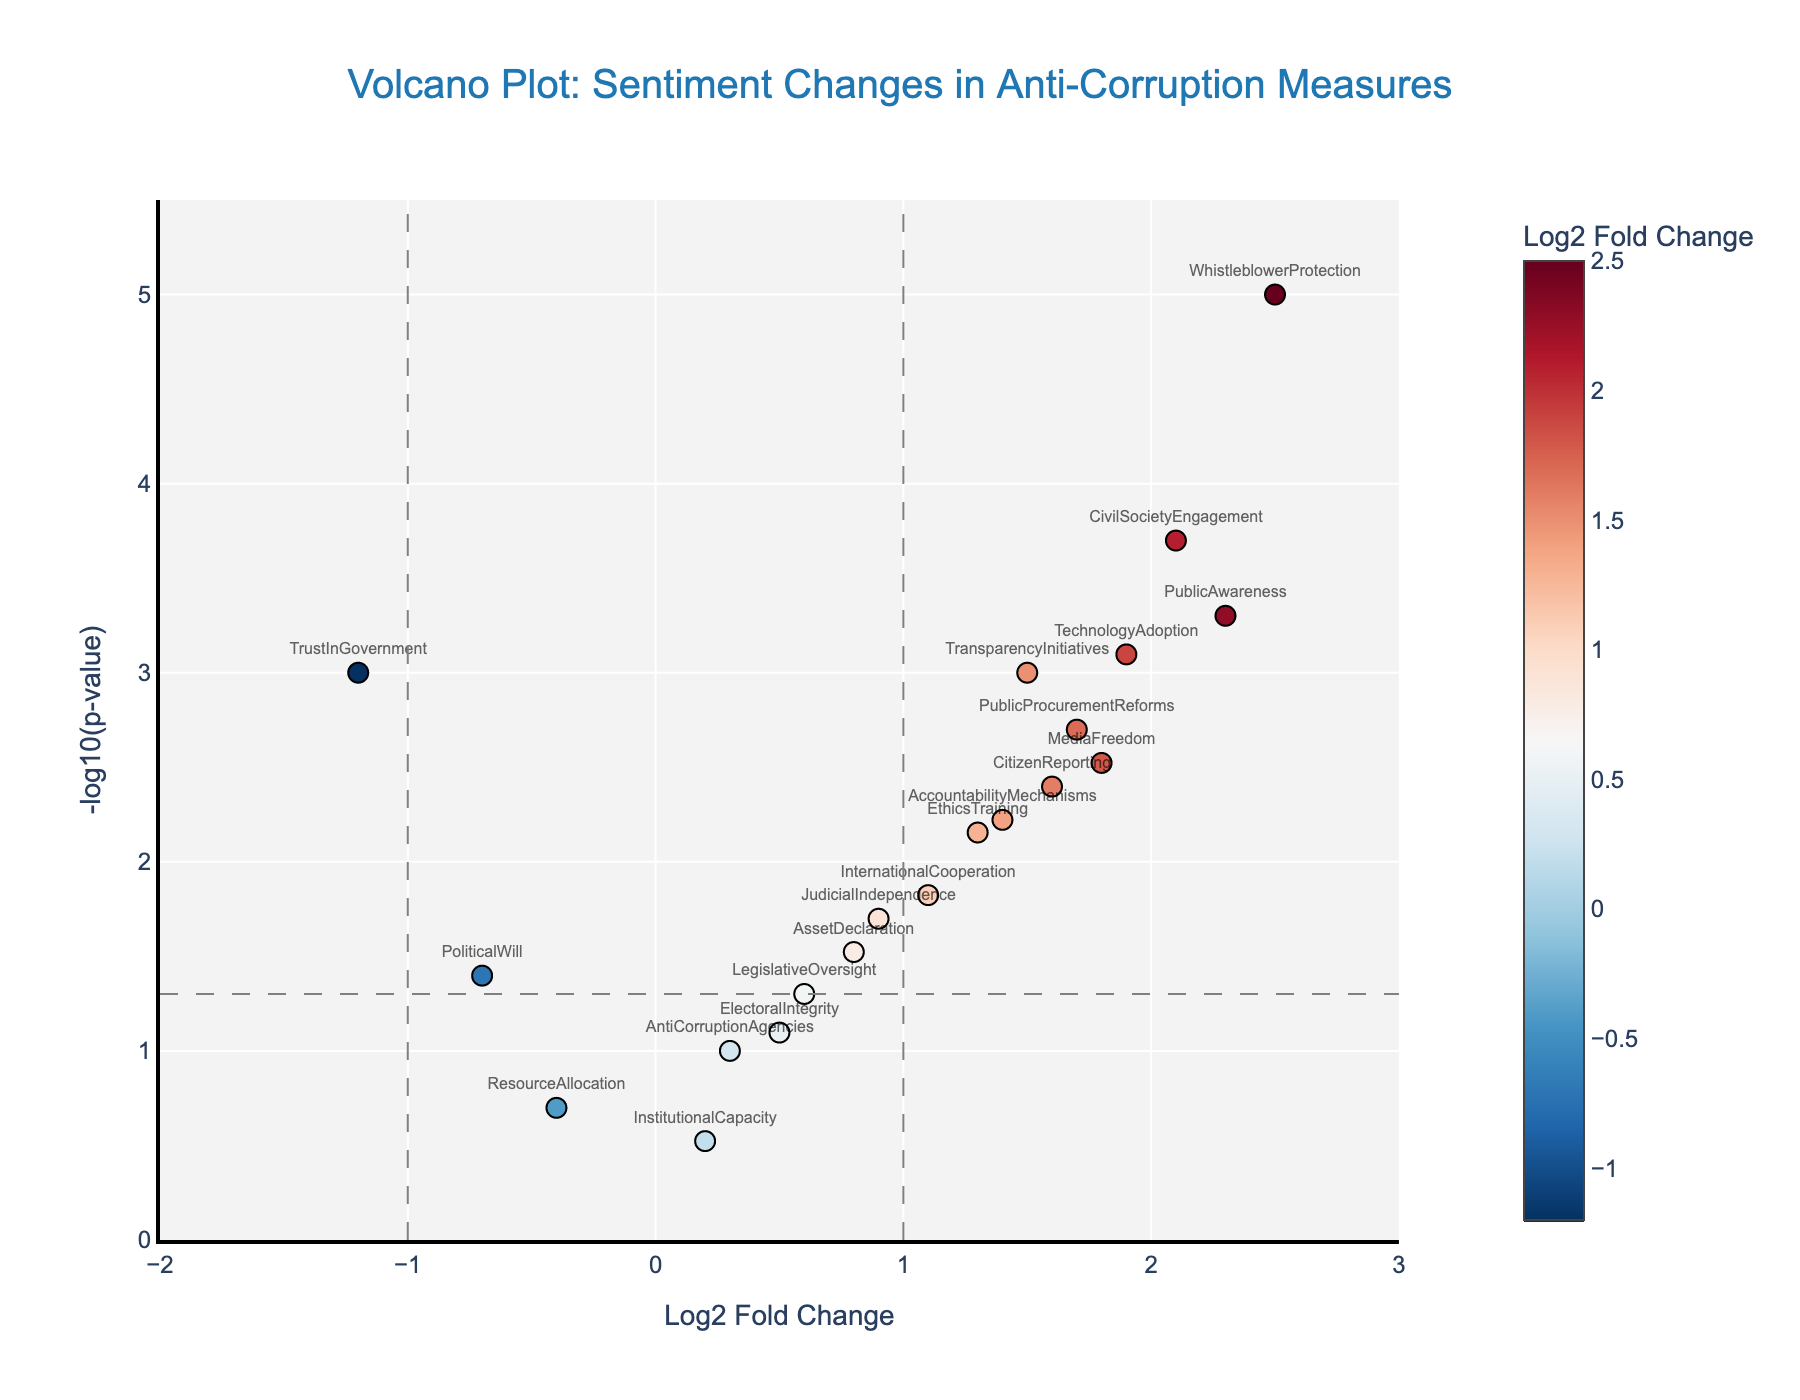How many data points have a p-value less than 0.05? In the figure, the horizontal dashed line represents the p-value threshold of 0.05. Data points above this line have a p-value less than 0.05. Counting these points visually, we find 15 points above the line.
Answer: 15 Which data point has the highest Log2 Fold Change? In the figure, the highest Log2 Fold Change can be identified as the point farthest to the right on the x-axis. This point corresponds to "WhistleblowerProtection" with a Log2 Fold Change of 2.5.
Answer: WhistleblowerProtection How many data points are both significantly altered (p-value < 0.05) and show increased sentiment (Log2 Fold Change > 0)? Points above the horizontal dashed line and to the right of the vertical line at Log2 Fold Change = 0 represent significantly altered and increased sentiments. Counting these, we find 12 points.
Answer: 12 Which data point is closest to the origin (Log2 Fold Change = 0, p-value = 1)? The origin in the volcano plot corresponds to a Log2 Fold Change of 0 and a -log10(p-value) of 0. The closest point to this is "InstitutionalCapacity" with a Log2 Fold Change of 0.2 and a p-value of 0.3.
Answer: InstitutionalCapacity Does any data point show a significant decrease in sentiment (Log2 Fold Change < -1 and p-value < 0.05)? Significant decrease in sentiment will be below the horizontal line at p-value = 0.05 and to the left of the vertical line at Log2 Fold Change = -1. Checking the plot, "TrustInGovernment" meets both criteria.
Answer: TrustInGovernment Which sentiment shows the second highest negative alteration? For negative alterations (Log2 Fold Change < 0), looking at the left-hand side, "ResourceAllocation" with a Log2 Fold Change of -0.4 is the second highest negative after "TrustInGovernment".
Answer: ResourceAllocation Which data points show a Log2 Fold Change greater than 1 and a p-value less than 0.001? These data points will be to the right of the vertical line at Log2 Fold Change = 1 and above the horizontal marker at p-value = 0.001. "PublicAwareness," "WhistleblowerProtection," and "CivilSocietyEngagement" fit these criteria.
Answer: PublicAwareness, WhistleblowerProtection, CivilSocietyEngagement 